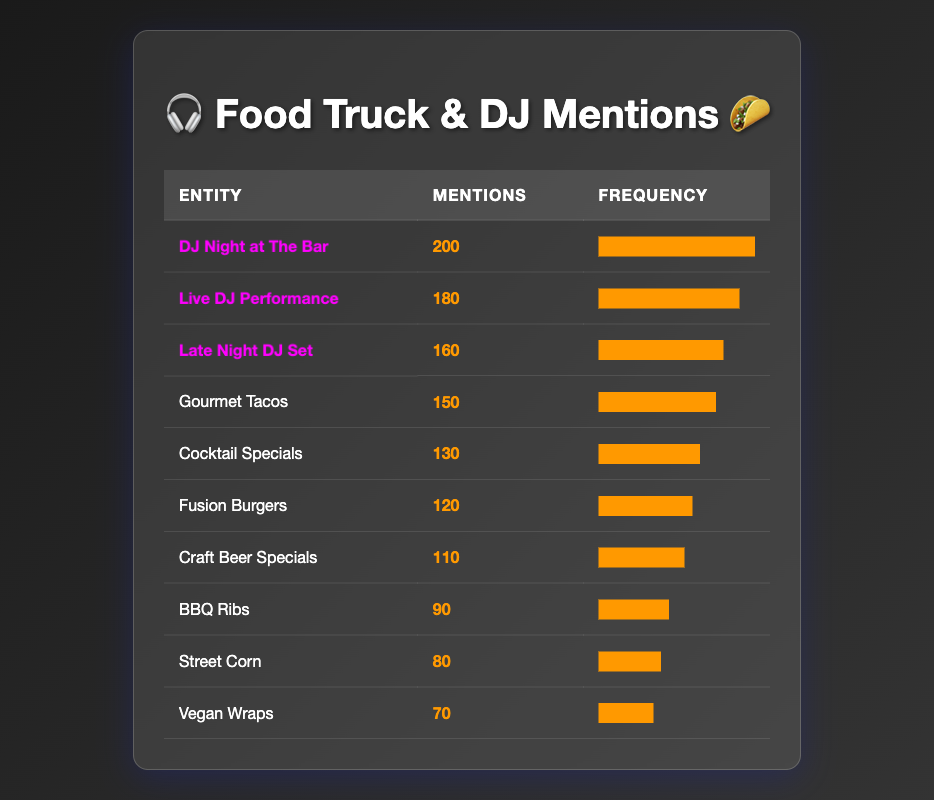What is the most mentioned food truck special? The table shows the number of mentions for each food truck special. "Gourmet Tacos" has 150 mentions, which is the highest among the food truck offerings.
Answer: Gourmet Tacos How many mentions did the DJ Night at The Bar receive? Looking at the table, "DJ Night at The Bar" has 200 mentions listed.
Answer: 200 Which DJ performance has the least number of mentions? The table lists all DJ performances and their mention counts. "Late Night DJ Set" has 160 mentions, which is the lowest among the listed DJ performances.
Answer: Late Night DJ Set What is the average number of mentions for all food truck specials? There are five food truck specials with mentions: 150 (Gourmet Tacos) + 120 (Fusion Burgers) + 90 (BBQ Ribs) + 110 (Craft Beer Specials) + 130 (Cocktail Specials) + 70 (Vegan Wraps) + 80 (Street Corn) = 800. Since there are 7 food truck specials, 800 divided by 7 gives an average of approximately 114.29.
Answer: 114.29 Did the total mentions of all DJ performances exceed the total mentions of food truck specials? First, we sum the mentions for DJ performances: 200 (DJ Night at The Bar) + 180 (Live DJ Performance) + 160 (Late Night DJ Set) = 540. Then, we sum the mentions for food truck specials: 150 + 120 + 90 + 110 + 130 + 70 + 80 = 800. Since 540 is less than 800, the answer is no.
Answer: No What is the difference in mentions between the top food truck special and the top DJ performance? The top food truck special "Gourmet Tacos" has 150 mentions, and the top DJ performance "DJ Night at The Bar" has 200 mentions. The difference is calculated by subtracting 150 from 200, resulting in 50.
Answer: 50 How many more mentions do DJ performances have compared to the Vegan Wraps? The mentions for DJ performances total up to 540, while "Vegan Wraps" has 70 mentions. We subtract 70 from 540, yielding a difference of 470.
Answer: 470 What percentage of the total mentions does Cocktail Specials account for? First, we calculate the total mentions: 800. Cocktail Specials have 130 mentions. The percentage is calculated as (130/800) * 100, which gives 16.25%.
Answer: 16.25% Which food truck special has mentions equal to or greater than 100? We check the mentions for each food truck special: "Gourmet Tacos" (150), "Fusion Burgers" (120), "BBQ Ribs" (90 - not counted), "Craft Beer Specials" (110), "Cocktail Specials" (130), "Vegan Wraps" (70 - not counted), and "Street Corn" (80 - not counted). The ones equal to or greater than 100 are "Gourmet Tacos," "Fusion Burgers," "Craft Beer Specials," and "Cocktail Specials."
Answer: 4 